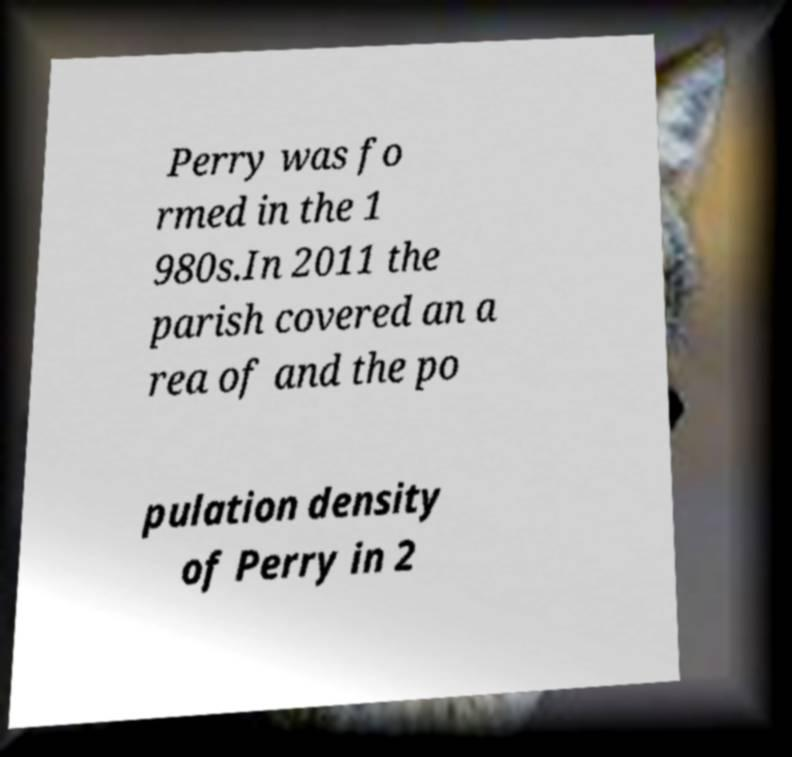What messages or text are displayed in this image? I need them in a readable, typed format. Perry was fo rmed in the 1 980s.In 2011 the parish covered an a rea of and the po pulation density of Perry in 2 